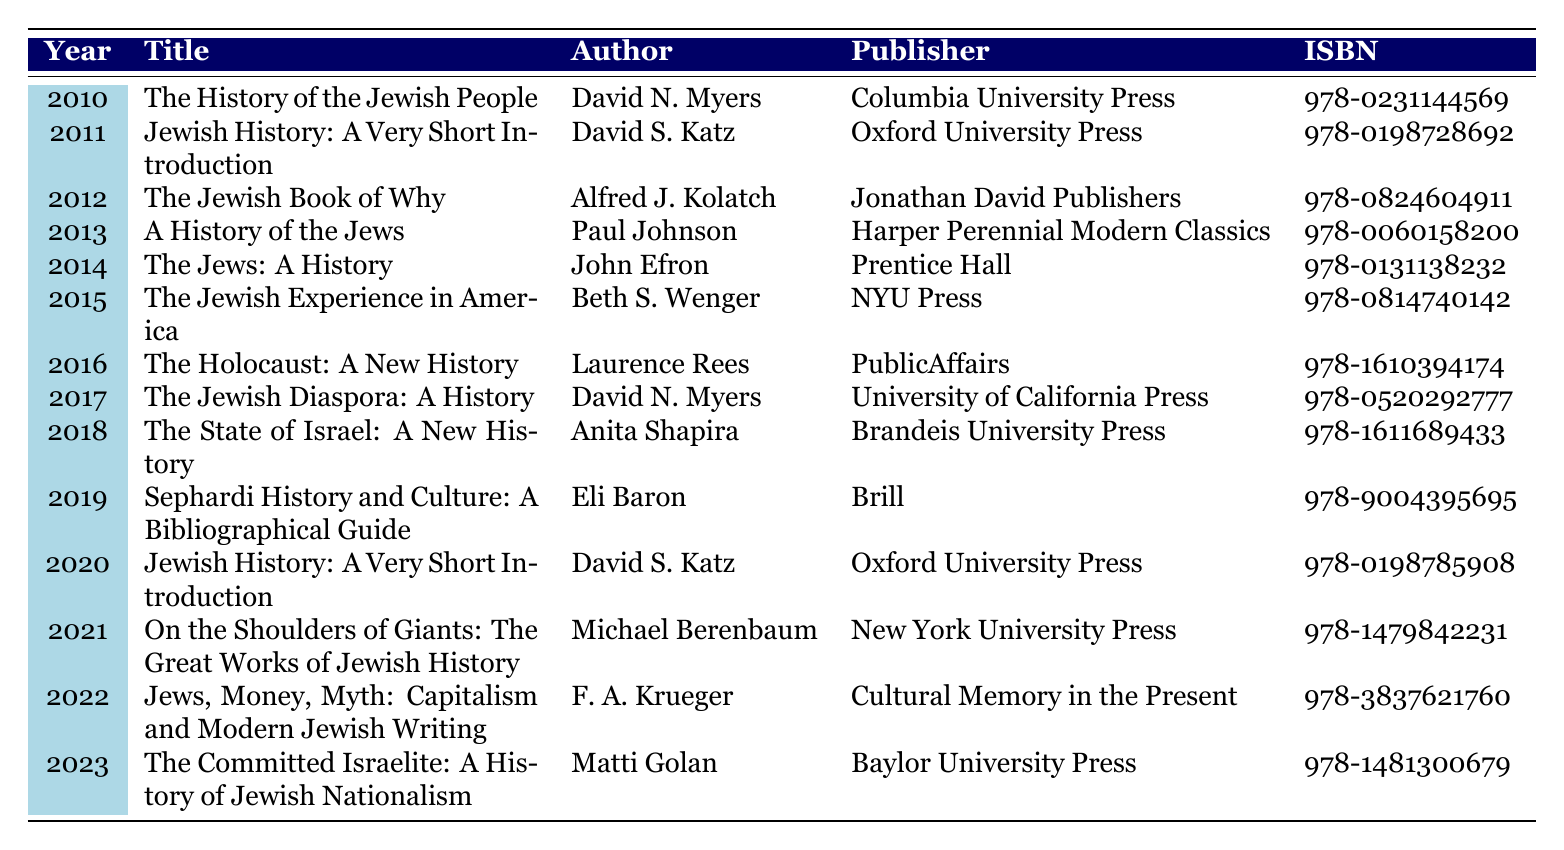What is the title of the book published in 2015? By looking at the table, we can find the entry for the year 2015, which lists "The Jewish Experience in America" as the title.
Answer: The Jewish Experience in America How many books were published in total from 2010 to 2023? The table includes entries for each year from 2010 to 2023, totaling 14 years, with one book listed per year. Thus, there are 14 books.
Answer: 14 Who is the author of the book "The Holocaust: A New History"? The entry for the book "The Holocaust: A New History" in the table shows that it was authored by Laurence Rees.
Answer: Laurence Rees In which year was "Jewish History: A Very Short Introduction" first published? The table indicates that "Jewish History: A Very Short Introduction" was published in 2011. However, it appears again in 2020. Since the question asks for the first publication year, we refer to the entry from 2011.
Answer: 2011 What is the average publication year of the books listed? The years from 2010 to 2023 can be summed (2010 + 2011 + ... + 2023 = 28526). There are 14 entries in total. The average year is calculated as 28526 / 14 ≈ 2037.43, which rounds to 2017 when considering whole years.
Answer: 2017 Was there a book published in 2018? The table shows an entry for 2018 titled "The State of Israel: A New History." Since there is indeed an entry for that year, the answer is yes.
Answer: Yes How many authors listed have published books more than once in this period? Reviewing the table, both David N. Myers (2010, 2017) and David S. Katz (2011, 2020) are noted as authors of multiple titles. So, there are two authors with at least two publications.
Answer: 2 Which publisher is associated with the highest number of published books? All publishers only have one book published from 2010 to 2023, so no publisher has a higher count. Each publisher appears only once in the data set.
Answer: None What is the title of the book published last in this dataset? The last entry in the table corresponds to the year 2023 and the title listed is "The Committed Israelite: A History of Jewish Nationalism."
Answer: The Committed Israelite: A History of Jewish Nationalism If we consider only the years 2010 to 2015, how many books were published? From 2010 to 2015, we can count the entries directly from the table: that's 6 (2010, 2011, 2012, 2013, 2014, and 2015).
Answer: 6 